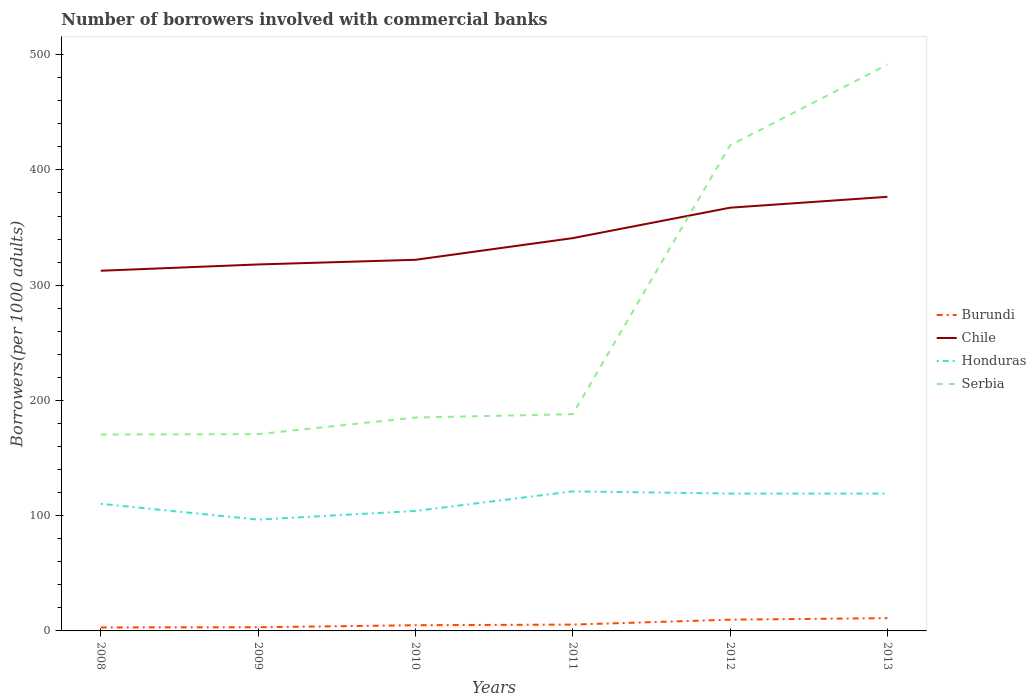Does the line corresponding to Chile intersect with the line corresponding to Honduras?
Give a very brief answer. No. Across all years, what is the maximum number of borrowers involved with commercial banks in Honduras?
Offer a very short reply. 96.61. What is the total number of borrowers involved with commercial banks in Serbia in the graph?
Provide a short and direct response. -14.4. What is the difference between the highest and the second highest number of borrowers involved with commercial banks in Chile?
Keep it short and to the point. 64.16. What is the difference between the highest and the lowest number of borrowers involved with commercial banks in Serbia?
Your answer should be compact. 2. Is the number of borrowers involved with commercial banks in Honduras strictly greater than the number of borrowers involved with commercial banks in Burundi over the years?
Provide a succinct answer. No. How many years are there in the graph?
Give a very brief answer. 6. What is the difference between two consecutive major ticks on the Y-axis?
Your answer should be compact. 100. Where does the legend appear in the graph?
Make the answer very short. Center right. What is the title of the graph?
Keep it short and to the point. Number of borrowers involved with commercial banks. Does "Suriname" appear as one of the legend labels in the graph?
Your answer should be very brief. No. What is the label or title of the X-axis?
Give a very brief answer. Years. What is the label or title of the Y-axis?
Provide a succinct answer. Borrowers(per 1000 adults). What is the Borrowers(per 1000 adults) of Burundi in 2008?
Keep it short and to the point. 3.02. What is the Borrowers(per 1000 adults) in Chile in 2008?
Keep it short and to the point. 312.53. What is the Borrowers(per 1000 adults) in Honduras in 2008?
Give a very brief answer. 110.29. What is the Borrowers(per 1000 adults) of Serbia in 2008?
Your response must be concise. 170.42. What is the Borrowers(per 1000 adults) of Burundi in 2009?
Make the answer very short. 3.19. What is the Borrowers(per 1000 adults) in Chile in 2009?
Provide a short and direct response. 317.99. What is the Borrowers(per 1000 adults) of Honduras in 2009?
Keep it short and to the point. 96.61. What is the Borrowers(per 1000 adults) of Serbia in 2009?
Your answer should be very brief. 170.75. What is the Borrowers(per 1000 adults) of Burundi in 2010?
Provide a succinct answer. 4.94. What is the Borrowers(per 1000 adults) of Chile in 2010?
Offer a very short reply. 322.03. What is the Borrowers(per 1000 adults) of Honduras in 2010?
Provide a succinct answer. 104.09. What is the Borrowers(per 1000 adults) of Serbia in 2010?
Offer a terse response. 185.15. What is the Borrowers(per 1000 adults) in Burundi in 2011?
Provide a succinct answer. 5.49. What is the Borrowers(per 1000 adults) in Chile in 2011?
Keep it short and to the point. 340.83. What is the Borrowers(per 1000 adults) in Honduras in 2011?
Your response must be concise. 121.07. What is the Borrowers(per 1000 adults) in Serbia in 2011?
Offer a very short reply. 188.1. What is the Borrowers(per 1000 adults) in Burundi in 2012?
Give a very brief answer. 9.75. What is the Borrowers(per 1000 adults) in Chile in 2012?
Provide a short and direct response. 367.24. What is the Borrowers(per 1000 adults) of Honduras in 2012?
Your answer should be very brief. 119.22. What is the Borrowers(per 1000 adults) of Serbia in 2012?
Ensure brevity in your answer.  421.31. What is the Borrowers(per 1000 adults) of Burundi in 2013?
Offer a very short reply. 11.09. What is the Borrowers(per 1000 adults) in Chile in 2013?
Make the answer very short. 376.7. What is the Borrowers(per 1000 adults) of Honduras in 2013?
Your response must be concise. 119.24. What is the Borrowers(per 1000 adults) in Serbia in 2013?
Make the answer very short. 491.32. Across all years, what is the maximum Borrowers(per 1000 adults) of Burundi?
Your answer should be compact. 11.09. Across all years, what is the maximum Borrowers(per 1000 adults) of Chile?
Offer a very short reply. 376.7. Across all years, what is the maximum Borrowers(per 1000 adults) in Honduras?
Give a very brief answer. 121.07. Across all years, what is the maximum Borrowers(per 1000 adults) in Serbia?
Offer a terse response. 491.32. Across all years, what is the minimum Borrowers(per 1000 adults) of Burundi?
Make the answer very short. 3.02. Across all years, what is the minimum Borrowers(per 1000 adults) of Chile?
Make the answer very short. 312.53. Across all years, what is the minimum Borrowers(per 1000 adults) in Honduras?
Your response must be concise. 96.61. Across all years, what is the minimum Borrowers(per 1000 adults) of Serbia?
Your response must be concise. 170.42. What is the total Borrowers(per 1000 adults) in Burundi in the graph?
Offer a very short reply. 37.47. What is the total Borrowers(per 1000 adults) in Chile in the graph?
Give a very brief answer. 2037.32. What is the total Borrowers(per 1000 adults) of Honduras in the graph?
Provide a succinct answer. 670.52. What is the total Borrowers(per 1000 adults) of Serbia in the graph?
Your answer should be compact. 1627.05. What is the difference between the Borrowers(per 1000 adults) in Burundi in 2008 and that in 2009?
Make the answer very short. -0.18. What is the difference between the Borrowers(per 1000 adults) in Chile in 2008 and that in 2009?
Provide a succinct answer. -5.46. What is the difference between the Borrowers(per 1000 adults) in Honduras in 2008 and that in 2009?
Offer a terse response. 13.68. What is the difference between the Borrowers(per 1000 adults) of Serbia in 2008 and that in 2009?
Make the answer very short. -0.33. What is the difference between the Borrowers(per 1000 adults) in Burundi in 2008 and that in 2010?
Your answer should be compact. -1.93. What is the difference between the Borrowers(per 1000 adults) in Chile in 2008 and that in 2010?
Offer a very short reply. -9.5. What is the difference between the Borrowers(per 1000 adults) in Honduras in 2008 and that in 2010?
Make the answer very short. 6.2. What is the difference between the Borrowers(per 1000 adults) in Serbia in 2008 and that in 2010?
Offer a terse response. -14.73. What is the difference between the Borrowers(per 1000 adults) of Burundi in 2008 and that in 2011?
Your response must be concise. -2.47. What is the difference between the Borrowers(per 1000 adults) of Chile in 2008 and that in 2011?
Provide a short and direct response. -28.3. What is the difference between the Borrowers(per 1000 adults) in Honduras in 2008 and that in 2011?
Provide a short and direct response. -10.78. What is the difference between the Borrowers(per 1000 adults) in Serbia in 2008 and that in 2011?
Your response must be concise. -17.67. What is the difference between the Borrowers(per 1000 adults) in Burundi in 2008 and that in 2012?
Offer a very short reply. -6.73. What is the difference between the Borrowers(per 1000 adults) in Chile in 2008 and that in 2012?
Provide a succinct answer. -54.71. What is the difference between the Borrowers(per 1000 adults) in Honduras in 2008 and that in 2012?
Give a very brief answer. -8.93. What is the difference between the Borrowers(per 1000 adults) in Serbia in 2008 and that in 2012?
Your answer should be compact. -250.88. What is the difference between the Borrowers(per 1000 adults) of Burundi in 2008 and that in 2013?
Provide a short and direct response. -8.07. What is the difference between the Borrowers(per 1000 adults) of Chile in 2008 and that in 2013?
Make the answer very short. -64.16. What is the difference between the Borrowers(per 1000 adults) of Honduras in 2008 and that in 2013?
Provide a succinct answer. -8.95. What is the difference between the Borrowers(per 1000 adults) in Serbia in 2008 and that in 2013?
Provide a succinct answer. -320.89. What is the difference between the Borrowers(per 1000 adults) of Burundi in 2009 and that in 2010?
Keep it short and to the point. -1.75. What is the difference between the Borrowers(per 1000 adults) in Chile in 2009 and that in 2010?
Provide a succinct answer. -4.04. What is the difference between the Borrowers(per 1000 adults) in Honduras in 2009 and that in 2010?
Offer a very short reply. -7.48. What is the difference between the Borrowers(per 1000 adults) in Serbia in 2009 and that in 2010?
Your answer should be compact. -14.4. What is the difference between the Borrowers(per 1000 adults) in Burundi in 2009 and that in 2011?
Your answer should be very brief. -2.3. What is the difference between the Borrowers(per 1000 adults) of Chile in 2009 and that in 2011?
Your answer should be very brief. -22.84. What is the difference between the Borrowers(per 1000 adults) of Honduras in 2009 and that in 2011?
Give a very brief answer. -24.46. What is the difference between the Borrowers(per 1000 adults) in Serbia in 2009 and that in 2011?
Keep it short and to the point. -17.35. What is the difference between the Borrowers(per 1000 adults) in Burundi in 2009 and that in 2012?
Your answer should be compact. -6.56. What is the difference between the Borrowers(per 1000 adults) in Chile in 2009 and that in 2012?
Your answer should be very brief. -49.25. What is the difference between the Borrowers(per 1000 adults) of Honduras in 2009 and that in 2012?
Your answer should be compact. -22.61. What is the difference between the Borrowers(per 1000 adults) of Serbia in 2009 and that in 2012?
Your answer should be compact. -250.56. What is the difference between the Borrowers(per 1000 adults) of Burundi in 2009 and that in 2013?
Your answer should be compact. -7.9. What is the difference between the Borrowers(per 1000 adults) in Chile in 2009 and that in 2013?
Provide a succinct answer. -58.7. What is the difference between the Borrowers(per 1000 adults) in Honduras in 2009 and that in 2013?
Make the answer very short. -22.63. What is the difference between the Borrowers(per 1000 adults) of Serbia in 2009 and that in 2013?
Your answer should be compact. -320.56. What is the difference between the Borrowers(per 1000 adults) in Burundi in 2010 and that in 2011?
Make the answer very short. -0.55. What is the difference between the Borrowers(per 1000 adults) in Chile in 2010 and that in 2011?
Ensure brevity in your answer.  -18.8. What is the difference between the Borrowers(per 1000 adults) in Honduras in 2010 and that in 2011?
Give a very brief answer. -16.98. What is the difference between the Borrowers(per 1000 adults) in Serbia in 2010 and that in 2011?
Offer a terse response. -2.94. What is the difference between the Borrowers(per 1000 adults) of Burundi in 2010 and that in 2012?
Give a very brief answer. -4.81. What is the difference between the Borrowers(per 1000 adults) in Chile in 2010 and that in 2012?
Offer a terse response. -45.21. What is the difference between the Borrowers(per 1000 adults) in Honduras in 2010 and that in 2012?
Your answer should be compact. -15.13. What is the difference between the Borrowers(per 1000 adults) of Serbia in 2010 and that in 2012?
Make the answer very short. -236.15. What is the difference between the Borrowers(per 1000 adults) in Burundi in 2010 and that in 2013?
Your response must be concise. -6.15. What is the difference between the Borrowers(per 1000 adults) of Chile in 2010 and that in 2013?
Your response must be concise. -54.66. What is the difference between the Borrowers(per 1000 adults) of Honduras in 2010 and that in 2013?
Ensure brevity in your answer.  -15.14. What is the difference between the Borrowers(per 1000 adults) of Serbia in 2010 and that in 2013?
Make the answer very short. -306.16. What is the difference between the Borrowers(per 1000 adults) in Burundi in 2011 and that in 2012?
Give a very brief answer. -4.26. What is the difference between the Borrowers(per 1000 adults) in Chile in 2011 and that in 2012?
Provide a short and direct response. -26.41. What is the difference between the Borrowers(per 1000 adults) of Honduras in 2011 and that in 2012?
Keep it short and to the point. 1.85. What is the difference between the Borrowers(per 1000 adults) in Serbia in 2011 and that in 2012?
Provide a succinct answer. -233.21. What is the difference between the Borrowers(per 1000 adults) of Burundi in 2011 and that in 2013?
Give a very brief answer. -5.6. What is the difference between the Borrowers(per 1000 adults) in Chile in 2011 and that in 2013?
Offer a terse response. -35.86. What is the difference between the Borrowers(per 1000 adults) in Honduras in 2011 and that in 2013?
Provide a succinct answer. 1.84. What is the difference between the Borrowers(per 1000 adults) in Serbia in 2011 and that in 2013?
Keep it short and to the point. -303.22. What is the difference between the Borrowers(per 1000 adults) of Burundi in 2012 and that in 2013?
Keep it short and to the point. -1.34. What is the difference between the Borrowers(per 1000 adults) in Chile in 2012 and that in 2013?
Ensure brevity in your answer.  -9.46. What is the difference between the Borrowers(per 1000 adults) in Honduras in 2012 and that in 2013?
Your answer should be very brief. -0.02. What is the difference between the Borrowers(per 1000 adults) in Serbia in 2012 and that in 2013?
Offer a very short reply. -70.01. What is the difference between the Borrowers(per 1000 adults) of Burundi in 2008 and the Borrowers(per 1000 adults) of Chile in 2009?
Ensure brevity in your answer.  -314.98. What is the difference between the Borrowers(per 1000 adults) of Burundi in 2008 and the Borrowers(per 1000 adults) of Honduras in 2009?
Provide a short and direct response. -93.59. What is the difference between the Borrowers(per 1000 adults) of Burundi in 2008 and the Borrowers(per 1000 adults) of Serbia in 2009?
Offer a very short reply. -167.74. What is the difference between the Borrowers(per 1000 adults) in Chile in 2008 and the Borrowers(per 1000 adults) in Honduras in 2009?
Your response must be concise. 215.92. What is the difference between the Borrowers(per 1000 adults) in Chile in 2008 and the Borrowers(per 1000 adults) in Serbia in 2009?
Your response must be concise. 141.78. What is the difference between the Borrowers(per 1000 adults) in Honduras in 2008 and the Borrowers(per 1000 adults) in Serbia in 2009?
Keep it short and to the point. -60.46. What is the difference between the Borrowers(per 1000 adults) in Burundi in 2008 and the Borrowers(per 1000 adults) in Chile in 2010?
Offer a very short reply. -319.02. What is the difference between the Borrowers(per 1000 adults) in Burundi in 2008 and the Borrowers(per 1000 adults) in Honduras in 2010?
Offer a very short reply. -101.08. What is the difference between the Borrowers(per 1000 adults) of Burundi in 2008 and the Borrowers(per 1000 adults) of Serbia in 2010?
Keep it short and to the point. -182.14. What is the difference between the Borrowers(per 1000 adults) in Chile in 2008 and the Borrowers(per 1000 adults) in Honduras in 2010?
Your answer should be very brief. 208.44. What is the difference between the Borrowers(per 1000 adults) of Chile in 2008 and the Borrowers(per 1000 adults) of Serbia in 2010?
Offer a terse response. 127.38. What is the difference between the Borrowers(per 1000 adults) of Honduras in 2008 and the Borrowers(per 1000 adults) of Serbia in 2010?
Keep it short and to the point. -74.86. What is the difference between the Borrowers(per 1000 adults) in Burundi in 2008 and the Borrowers(per 1000 adults) in Chile in 2011?
Provide a short and direct response. -337.82. What is the difference between the Borrowers(per 1000 adults) in Burundi in 2008 and the Borrowers(per 1000 adults) in Honduras in 2011?
Ensure brevity in your answer.  -118.06. What is the difference between the Borrowers(per 1000 adults) of Burundi in 2008 and the Borrowers(per 1000 adults) of Serbia in 2011?
Your answer should be compact. -185.08. What is the difference between the Borrowers(per 1000 adults) in Chile in 2008 and the Borrowers(per 1000 adults) in Honduras in 2011?
Ensure brevity in your answer.  191.46. What is the difference between the Borrowers(per 1000 adults) in Chile in 2008 and the Borrowers(per 1000 adults) in Serbia in 2011?
Your response must be concise. 124.43. What is the difference between the Borrowers(per 1000 adults) of Honduras in 2008 and the Borrowers(per 1000 adults) of Serbia in 2011?
Your answer should be very brief. -77.81. What is the difference between the Borrowers(per 1000 adults) in Burundi in 2008 and the Borrowers(per 1000 adults) in Chile in 2012?
Provide a succinct answer. -364.22. What is the difference between the Borrowers(per 1000 adults) in Burundi in 2008 and the Borrowers(per 1000 adults) in Honduras in 2012?
Offer a very short reply. -116.21. What is the difference between the Borrowers(per 1000 adults) in Burundi in 2008 and the Borrowers(per 1000 adults) in Serbia in 2012?
Your answer should be very brief. -418.29. What is the difference between the Borrowers(per 1000 adults) of Chile in 2008 and the Borrowers(per 1000 adults) of Honduras in 2012?
Ensure brevity in your answer.  193.31. What is the difference between the Borrowers(per 1000 adults) in Chile in 2008 and the Borrowers(per 1000 adults) in Serbia in 2012?
Give a very brief answer. -108.78. What is the difference between the Borrowers(per 1000 adults) of Honduras in 2008 and the Borrowers(per 1000 adults) of Serbia in 2012?
Give a very brief answer. -311.02. What is the difference between the Borrowers(per 1000 adults) in Burundi in 2008 and the Borrowers(per 1000 adults) in Chile in 2013?
Ensure brevity in your answer.  -373.68. What is the difference between the Borrowers(per 1000 adults) of Burundi in 2008 and the Borrowers(per 1000 adults) of Honduras in 2013?
Make the answer very short. -116.22. What is the difference between the Borrowers(per 1000 adults) in Burundi in 2008 and the Borrowers(per 1000 adults) in Serbia in 2013?
Give a very brief answer. -488.3. What is the difference between the Borrowers(per 1000 adults) of Chile in 2008 and the Borrowers(per 1000 adults) of Honduras in 2013?
Give a very brief answer. 193.29. What is the difference between the Borrowers(per 1000 adults) of Chile in 2008 and the Borrowers(per 1000 adults) of Serbia in 2013?
Your answer should be compact. -178.78. What is the difference between the Borrowers(per 1000 adults) in Honduras in 2008 and the Borrowers(per 1000 adults) in Serbia in 2013?
Provide a short and direct response. -381.02. What is the difference between the Borrowers(per 1000 adults) in Burundi in 2009 and the Borrowers(per 1000 adults) in Chile in 2010?
Offer a terse response. -318.84. What is the difference between the Borrowers(per 1000 adults) in Burundi in 2009 and the Borrowers(per 1000 adults) in Honduras in 2010?
Offer a very short reply. -100.9. What is the difference between the Borrowers(per 1000 adults) in Burundi in 2009 and the Borrowers(per 1000 adults) in Serbia in 2010?
Offer a very short reply. -181.96. What is the difference between the Borrowers(per 1000 adults) of Chile in 2009 and the Borrowers(per 1000 adults) of Honduras in 2010?
Your answer should be compact. 213.9. What is the difference between the Borrowers(per 1000 adults) in Chile in 2009 and the Borrowers(per 1000 adults) in Serbia in 2010?
Offer a terse response. 132.84. What is the difference between the Borrowers(per 1000 adults) of Honduras in 2009 and the Borrowers(per 1000 adults) of Serbia in 2010?
Provide a short and direct response. -88.54. What is the difference between the Borrowers(per 1000 adults) in Burundi in 2009 and the Borrowers(per 1000 adults) in Chile in 2011?
Your answer should be compact. -337.64. What is the difference between the Borrowers(per 1000 adults) of Burundi in 2009 and the Borrowers(per 1000 adults) of Honduras in 2011?
Your response must be concise. -117.88. What is the difference between the Borrowers(per 1000 adults) in Burundi in 2009 and the Borrowers(per 1000 adults) in Serbia in 2011?
Your answer should be very brief. -184.91. What is the difference between the Borrowers(per 1000 adults) in Chile in 2009 and the Borrowers(per 1000 adults) in Honduras in 2011?
Your response must be concise. 196.92. What is the difference between the Borrowers(per 1000 adults) of Chile in 2009 and the Borrowers(per 1000 adults) of Serbia in 2011?
Give a very brief answer. 129.89. What is the difference between the Borrowers(per 1000 adults) in Honduras in 2009 and the Borrowers(per 1000 adults) in Serbia in 2011?
Your answer should be compact. -91.49. What is the difference between the Borrowers(per 1000 adults) of Burundi in 2009 and the Borrowers(per 1000 adults) of Chile in 2012?
Your response must be concise. -364.05. What is the difference between the Borrowers(per 1000 adults) in Burundi in 2009 and the Borrowers(per 1000 adults) in Honduras in 2012?
Make the answer very short. -116.03. What is the difference between the Borrowers(per 1000 adults) of Burundi in 2009 and the Borrowers(per 1000 adults) of Serbia in 2012?
Provide a short and direct response. -418.12. What is the difference between the Borrowers(per 1000 adults) in Chile in 2009 and the Borrowers(per 1000 adults) in Honduras in 2012?
Offer a very short reply. 198.77. What is the difference between the Borrowers(per 1000 adults) in Chile in 2009 and the Borrowers(per 1000 adults) in Serbia in 2012?
Your response must be concise. -103.32. What is the difference between the Borrowers(per 1000 adults) of Honduras in 2009 and the Borrowers(per 1000 adults) of Serbia in 2012?
Ensure brevity in your answer.  -324.7. What is the difference between the Borrowers(per 1000 adults) in Burundi in 2009 and the Borrowers(per 1000 adults) in Chile in 2013?
Your answer should be very brief. -373.5. What is the difference between the Borrowers(per 1000 adults) in Burundi in 2009 and the Borrowers(per 1000 adults) in Honduras in 2013?
Your answer should be compact. -116.05. What is the difference between the Borrowers(per 1000 adults) of Burundi in 2009 and the Borrowers(per 1000 adults) of Serbia in 2013?
Offer a terse response. -488.12. What is the difference between the Borrowers(per 1000 adults) in Chile in 2009 and the Borrowers(per 1000 adults) in Honduras in 2013?
Keep it short and to the point. 198.75. What is the difference between the Borrowers(per 1000 adults) in Chile in 2009 and the Borrowers(per 1000 adults) in Serbia in 2013?
Your answer should be compact. -173.32. What is the difference between the Borrowers(per 1000 adults) of Honduras in 2009 and the Borrowers(per 1000 adults) of Serbia in 2013?
Provide a succinct answer. -394.71. What is the difference between the Borrowers(per 1000 adults) in Burundi in 2010 and the Borrowers(per 1000 adults) in Chile in 2011?
Keep it short and to the point. -335.89. What is the difference between the Borrowers(per 1000 adults) of Burundi in 2010 and the Borrowers(per 1000 adults) of Honduras in 2011?
Provide a succinct answer. -116.13. What is the difference between the Borrowers(per 1000 adults) in Burundi in 2010 and the Borrowers(per 1000 adults) in Serbia in 2011?
Offer a very short reply. -183.16. What is the difference between the Borrowers(per 1000 adults) of Chile in 2010 and the Borrowers(per 1000 adults) of Honduras in 2011?
Your response must be concise. 200.96. What is the difference between the Borrowers(per 1000 adults) in Chile in 2010 and the Borrowers(per 1000 adults) in Serbia in 2011?
Your answer should be compact. 133.93. What is the difference between the Borrowers(per 1000 adults) of Honduras in 2010 and the Borrowers(per 1000 adults) of Serbia in 2011?
Give a very brief answer. -84.01. What is the difference between the Borrowers(per 1000 adults) in Burundi in 2010 and the Borrowers(per 1000 adults) in Chile in 2012?
Ensure brevity in your answer.  -362.3. What is the difference between the Borrowers(per 1000 adults) of Burundi in 2010 and the Borrowers(per 1000 adults) of Honduras in 2012?
Your answer should be compact. -114.28. What is the difference between the Borrowers(per 1000 adults) in Burundi in 2010 and the Borrowers(per 1000 adults) in Serbia in 2012?
Keep it short and to the point. -416.37. What is the difference between the Borrowers(per 1000 adults) in Chile in 2010 and the Borrowers(per 1000 adults) in Honduras in 2012?
Make the answer very short. 202.81. What is the difference between the Borrowers(per 1000 adults) of Chile in 2010 and the Borrowers(per 1000 adults) of Serbia in 2012?
Your response must be concise. -99.28. What is the difference between the Borrowers(per 1000 adults) of Honduras in 2010 and the Borrowers(per 1000 adults) of Serbia in 2012?
Your response must be concise. -317.21. What is the difference between the Borrowers(per 1000 adults) in Burundi in 2010 and the Borrowers(per 1000 adults) in Chile in 2013?
Ensure brevity in your answer.  -371.75. What is the difference between the Borrowers(per 1000 adults) of Burundi in 2010 and the Borrowers(per 1000 adults) of Honduras in 2013?
Your response must be concise. -114.3. What is the difference between the Borrowers(per 1000 adults) in Burundi in 2010 and the Borrowers(per 1000 adults) in Serbia in 2013?
Your answer should be compact. -486.37. What is the difference between the Borrowers(per 1000 adults) in Chile in 2010 and the Borrowers(per 1000 adults) in Honduras in 2013?
Keep it short and to the point. 202.79. What is the difference between the Borrowers(per 1000 adults) in Chile in 2010 and the Borrowers(per 1000 adults) in Serbia in 2013?
Your answer should be compact. -169.28. What is the difference between the Borrowers(per 1000 adults) of Honduras in 2010 and the Borrowers(per 1000 adults) of Serbia in 2013?
Give a very brief answer. -387.22. What is the difference between the Borrowers(per 1000 adults) of Burundi in 2011 and the Borrowers(per 1000 adults) of Chile in 2012?
Offer a terse response. -361.75. What is the difference between the Borrowers(per 1000 adults) in Burundi in 2011 and the Borrowers(per 1000 adults) in Honduras in 2012?
Provide a short and direct response. -113.73. What is the difference between the Borrowers(per 1000 adults) in Burundi in 2011 and the Borrowers(per 1000 adults) in Serbia in 2012?
Offer a very short reply. -415.82. What is the difference between the Borrowers(per 1000 adults) in Chile in 2011 and the Borrowers(per 1000 adults) in Honduras in 2012?
Your answer should be compact. 221.61. What is the difference between the Borrowers(per 1000 adults) of Chile in 2011 and the Borrowers(per 1000 adults) of Serbia in 2012?
Make the answer very short. -80.47. What is the difference between the Borrowers(per 1000 adults) of Honduras in 2011 and the Borrowers(per 1000 adults) of Serbia in 2012?
Offer a very short reply. -300.24. What is the difference between the Borrowers(per 1000 adults) in Burundi in 2011 and the Borrowers(per 1000 adults) in Chile in 2013?
Make the answer very short. -371.21. What is the difference between the Borrowers(per 1000 adults) in Burundi in 2011 and the Borrowers(per 1000 adults) in Honduras in 2013?
Your answer should be very brief. -113.75. What is the difference between the Borrowers(per 1000 adults) in Burundi in 2011 and the Borrowers(per 1000 adults) in Serbia in 2013?
Provide a succinct answer. -485.83. What is the difference between the Borrowers(per 1000 adults) of Chile in 2011 and the Borrowers(per 1000 adults) of Honduras in 2013?
Keep it short and to the point. 221.6. What is the difference between the Borrowers(per 1000 adults) of Chile in 2011 and the Borrowers(per 1000 adults) of Serbia in 2013?
Give a very brief answer. -150.48. What is the difference between the Borrowers(per 1000 adults) of Honduras in 2011 and the Borrowers(per 1000 adults) of Serbia in 2013?
Your response must be concise. -370.24. What is the difference between the Borrowers(per 1000 adults) of Burundi in 2012 and the Borrowers(per 1000 adults) of Chile in 2013?
Give a very brief answer. -366.95. What is the difference between the Borrowers(per 1000 adults) of Burundi in 2012 and the Borrowers(per 1000 adults) of Honduras in 2013?
Ensure brevity in your answer.  -109.49. What is the difference between the Borrowers(per 1000 adults) in Burundi in 2012 and the Borrowers(per 1000 adults) in Serbia in 2013?
Give a very brief answer. -481.56. What is the difference between the Borrowers(per 1000 adults) of Chile in 2012 and the Borrowers(per 1000 adults) of Honduras in 2013?
Keep it short and to the point. 248. What is the difference between the Borrowers(per 1000 adults) in Chile in 2012 and the Borrowers(per 1000 adults) in Serbia in 2013?
Provide a succinct answer. -124.08. What is the difference between the Borrowers(per 1000 adults) in Honduras in 2012 and the Borrowers(per 1000 adults) in Serbia in 2013?
Your response must be concise. -372.09. What is the average Borrowers(per 1000 adults) of Burundi per year?
Your response must be concise. 6.25. What is the average Borrowers(per 1000 adults) of Chile per year?
Keep it short and to the point. 339.55. What is the average Borrowers(per 1000 adults) of Honduras per year?
Your response must be concise. 111.75. What is the average Borrowers(per 1000 adults) in Serbia per year?
Offer a terse response. 271.18. In the year 2008, what is the difference between the Borrowers(per 1000 adults) in Burundi and Borrowers(per 1000 adults) in Chile?
Your answer should be compact. -309.52. In the year 2008, what is the difference between the Borrowers(per 1000 adults) in Burundi and Borrowers(per 1000 adults) in Honduras?
Provide a short and direct response. -107.28. In the year 2008, what is the difference between the Borrowers(per 1000 adults) in Burundi and Borrowers(per 1000 adults) in Serbia?
Make the answer very short. -167.41. In the year 2008, what is the difference between the Borrowers(per 1000 adults) in Chile and Borrowers(per 1000 adults) in Honduras?
Make the answer very short. 202.24. In the year 2008, what is the difference between the Borrowers(per 1000 adults) in Chile and Borrowers(per 1000 adults) in Serbia?
Provide a succinct answer. 142.11. In the year 2008, what is the difference between the Borrowers(per 1000 adults) of Honduras and Borrowers(per 1000 adults) of Serbia?
Give a very brief answer. -60.13. In the year 2009, what is the difference between the Borrowers(per 1000 adults) in Burundi and Borrowers(per 1000 adults) in Chile?
Ensure brevity in your answer.  -314.8. In the year 2009, what is the difference between the Borrowers(per 1000 adults) in Burundi and Borrowers(per 1000 adults) in Honduras?
Your answer should be very brief. -93.42. In the year 2009, what is the difference between the Borrowers(per 1000 adults) of Burundi and Borrowers(per 1000 adults) of Serbia?
Provide a succinct answer. -167.56. In the year 2009, what is the difference between the Borrowers(per 1000 adults) in Chile and Borrowers(per 1000 adults) in Honduras?
Provide a short and direct response. 221.38. In the year 2009, what is the difference between the Borrowers(per 1000 adults) of Chile and Borrowers(per 1000 adults) of Serbia?
Offer a terse response. 147.24. In the year 2009, what is the difference between the Borrowers(per 1000 adults) in Honduras and Borrowers(per 1000 adults) in Serbia?
Provide a succinct answer. -74.14. In the year 2010, what is the difference between the Borrowers(per 1000 adults) of Burundi and Borrowers(per 1000 adults) of Chile?
Keep it short and to the point. -317.09. In the year 2010, what is the difference between the Borrowers(per 1000 adults) in Burundi and Borrowers(per 1000 adults) in Honduras?
Offer a very short reply. -99.15. In the year 2010, what is the difference between the Borrowers(per 1000 adults) of Burundi and Borrowers(per 1000 adults) of Serbia?
Make the answer very short. -180.21. In the year 2010, what is the difference between the Borrowers(per 1000 adults) of Chile and Borrowers(per 1000 adults) of Honduras?
Provide a succinct answer. 217.94. In the year 2010, what is the difference between the Borrowers(per 1000 adults) of Chile and Borrowers(per 1000 adults) of Serbia?
Ensure brevity in your answer.  136.88. In the year 2010, what is the difference between the Borrowers(per 1000 adults) of Honduras and Borrowers(per 1000 adults) of Serbia?
Make the answer very short. -81.06. In the year 2011, what is the difference between the Borrowers(per 1000 adults) in Burundi and Borrowers(per 1000 adults) in Chile?
Ensure brevity in your answer.  -335.35. In the year 2011, what is the difference between the Borrowers(per 1000 adults) of Burundi and Borrowers(per 1000 adults) of Honduras?
Provide a succinct answer. -115.58. In the year 2011, what is the difference between the Borrowers(per 1000 adults) in Burundi and Borrowers(per 1000 adults) in Serbia?
Your answer should be compact. -182.61. In the year 2011, what is the difference between the Borrowers(per 1000 adults) of Chile and Borrowers(per 1000 adults) of Honduras?
Your answer should be very brief. 219.76. In the year 2011, what is the difference between the Borrowers(per 1000 adults) in Chile and Borrowers(per 1000 adults) in Serbia?
Ensure brevity in your answer.  152.73. In the year 2011, what is the difference between the Borrowers(per 1000 adults) in Honduras and Borrowers(per 1000 adults) in Serbia?
Keep it short and to the point. -67.03. In the year 2012, what is the difference between the Borrowers(per 1000 adults) in Burundi and Borrowers(per 1000 adults) in Chile?
Give a very brief answer. -357.49. In the year 2012, what is the difference between the Borrowers(per 1000 adults) in Burundi and Borrowers(per 1000 adults) in Honduras?
Offer a very short reply. -109.47. In the year 2012, what is the difference between the Borrowers(per 1000 adults) in Burundi and Borrowers(per 1000 adults) in Serbia?
Provide a short and direct response. -411.56. In the year 2012, what is the difference between the Borrowers(per 1000 adults) of Chile and Borrowers(per 1000 adults) of Honduras?
Your answer should be compact. 248.02. In the year 2012, what is the difference between the Borrowers(per 1000 adults) of Chile and Borrowers(per 1000 adults) of Serbia?
Your answer should be very brief. -54.07. In the year 2012, what is the difference between the Borrowers(per 1000 adults) of Honduras and Borrowers(per 1000 adults) of Serbia?
Give a very brief answer. -302.09. In the year 2013, what is the difference between the Borrowers(per 1000 adults) of Burundi and Borrowers(per 1000 adults) of Chile?
Offer a very short reply. -365.61. In the year 2013, what is the difference between the Borrowers(per 1000 adults) of Burundi and Borrowers(per 1000 adults) of Honduras?
Your answer should be very brief. -108.15. In the year 2013, what is the difference between the Borrowers(per 1000 adults) in Burundi and Borrowers(per 1000 adults) in Serbia?
Offer a very short reply. -480.23. In the year 2013, what is the difference between the Borrowers(per 1000 adults) of Chile and Borrowers(per 1000 adults) of Honduras?
Your answer should be compact. 257.46. In the year 2013, what is the difference between the Borrowers(per 1000 adults) of Chile and Borrowers(per 1000 adults) of Serbia?
Provide a short and direct response. -114.62. In the year 2013, what is the difference between the Borrowers(per 1000 adults) of Honduras and Borrowers(per 1000 adults) of Serbia?
Offer a terse response. -372.08. What is the ratio of the Borrowers(per 1000 adults) in Burundi in 2008 to that in 2009?
Your response must be concise. 0.94. What is the ratio of the Borrowers(per 1000 adults) in Chile in 2008 to that in 2009?
Give a very brief answer. 0.98. What is the ratio of the Borrowers(per 1000 adults) of Honduras in 2008 to that in 2009?
Your answer should be very brief. 1.14. What is the ratio of the Borrowers(per 1000 adults) of Serbia in 2008 to that in 2009?
Your response must be concise. 1. What is the ratio of the Borrowers(per 1000 adults) in Burundi in 2008 to that in 2010?
Your answer should be compact. 0.61. What is the ratio of the Borrowers(per 1000 adults) of Chile in 2008 to that in 2010?
Make the answer very short. 0.97. What is the ratio of the Borrowers(per 1000 adults) of Honduras in 2008 to that in 2010?
Ensure brevity in your answer.  1.06. What is the ratio of the Borrowers(per 1000 adults) of Serbia in 2008 to that in 2010?
Give a very brief answer. 0.92. What is the ratio of the Borrowers(per 1000 adults) in Burundi in 2008 to that in 2011?
Ensure brevity in your answer.  0.55. What is the ratio of the Borrowers(per 1000 adults) of Chile in 2008 to that in 2011?
Make the answer very short. 0.92. What is the ratio of the Borrowers(per 1000 adults) in Honduras in 2008 to that in 2011?
Provide a succinct answer. 0.91. What is the ratio of the Borrowers(per 1000 adults) of Serbia in 2008 to that in 2011?
Your answer should be compact. 0.91. What is the ratio of the Borrowers(per 1000 adults) of Burundi in 2008 to that in 2012?
Your answer should be very brief. 0.31. What is the ratio of the Borrowers(per 1000 adults) in Chile in 2008 to that in 2012?
Your response must be concise. 0.85. What is the ratio of the Borrowers(per 1000 adults) of Honduras in 2008 to that in 2012?
Offer a terse response. 0.93. What is the ratio of the Borrowers(per 1000 adults) of Serbia in 2008 to that in 2012?
Offer a very short reply. 0.4. What is the ratio of the Borrowers(per 1000 adults) in Burundi in 2008 to that in 2013?
Provide a succinct answer. 0.27. What is the ratio of the Borrowers(per 1000 adults) of Chile in 2008 to that in 2013?
Give a very brief answer. 0.83. What is the ratio of the Borrowers(per 1000 adults) of Honduras in 2008 to that in 2013?
Your answer should be very brief. 0.93. What is the ratio of the Borrowers(per 1000 adults) of Serbia in 2008 to that in 2013?
Make the answer very short. 0.35. What is the ratio of the Borrowers(per 1000 adults) of Burundi in 2009 to that in 2010?
Offer a very short reply. 0.65. What is the ratio of the Borrowers(per 1000 adults) of Chile in 2009 to that in 2010?
Give a very brief answer. 0.99. What is the ratio of the Borrowers(per 1000 adults) of Honduras in 2009 to that in 2010?
Your answer should be compact. 0.93. What is the ratio of the Borrowers(per 1000 adults) of Serbia in 2009 to that in 2010?
Provide a succinct answer. 0.92. What is the ratio of the Borrowers(per 1000 adults) of Burundi in 2009 to that in 2011?
Your answer should be very brief. 0.58. What is the ratio of the Borrowers(per 1000 adults) of Chile in 2009 to that in 2011?
Your response must be concise. 0.93. What is the ratio of the Borrowers(per 1000 adults) in Honduras in 2009 to that in 2011?
Your response must be concise. 0.8. What is the ratio of the Borrowers(per 1000 adults) of Serbia in 2009 to that in 2011?
Offer a very short reply. 0.91. What is the ratio of the Borrowers(per 1000 adults) in Burundi in 2009 to that in 2012?
Offer a terse response. 0.33. What is the ratio of the Borrowers(per 1000 adults) of Chile in 2009 to that in 2012?
Offer a very short reply. 0.87. What is the ratio of the Borrowers(per 1000 adults) in Honduras in 2009 to that in 2012?
Provide a short and direct response. 0.81. What is the ratio of the Borrowers(per 1000 adults) of Serbia in 2009 to that in 2012?
Keep it short and to the point. 0.41. What is the ratio of the Borrowers(per 1000 adults) of Burundi in 2009 to that in 2013?
Give a very brief answer. 0.29. What is the ratio of the Borrowers(per 1000 adults) of Chile in 2009 to that in 2013?
Provide a short and direct response. 0.84. What is the ratio of the Borrowers(per 1000 adults) of Honduras in 2009 to that in 2013?
Give a very brief answer. 0.81. What is the ratio of the Borrowers(per 1000 adults) of Serbia in 2009 to that in 2013?
Make the answer very short. 0.35. What is the ratio of the Borrowers(per 1000 adults) in Burundi in 2010 to that in 2011?
Keep it short and to the point. 0.9. What is the ratio of the Borrowers(per 1000 adults) in Chile in 2010 to that in 2011?
Your response must be concise. 0.94. What is the ratio of the Borrowers(per 1000 adults) of Honduras in 2010 to that in 2011?
Your response must be concise. 0.86. What is the ratio of the Borrowers(per 1000 adults) in Serbia in 2010 to that in 2011?
Keep it short and to the point. 0.98. What is the ratio of the Borrowers(per 1000 adults) of Burundi in 2010 to that in 2012?
Your response must be concise. 0.51. What is the ratio of the Borrowers(per 1000 adults) in Chile in 2010 to that in 2012?
Keep it short and to the point. 0.88. What is the ratio of the Borrowers(per 1000 adults) in Honduras in 2010 to that in 2012?
Your answer should be compact. 0.87. What is the ratio of the Borrowers(per 1000 adults) of Serbia in 2010 to that in 2012?
Make the answer very short. 0.44. What is the ratio of the Borrowers(per 1000 adults) in Burundi in 2010 to that in 2013?
Your response must be concise. 0.45. What is the ratio of the Borrowers(per 1000 adults) of Chile in 2010 to that in 2013?
Your answer should be compact. 0.85. What is the ratio of the Borrowers(per 1000 adults) in Honduras in 2010 to that in 2013?
Give a very brief answer. 0.87. What is the ratio of the Borrowers(per 1000 adults) of Serbia in 2010 to that in 2013?
Provide a short and direct response. 0.38. What is the ratio of the Borrowers(per 1000 adults) in Burundi in 2011 to that in 2012?
Your answer should be very brief. 0.56. What is the ratio of the Borrowers(per 1000 adults) in Chile in 2011 to that in 2012?
Your answer should be compact. 0.93. What is the ratio of the Borrowers(per 1000 adults) in Honduras in 2011 to that in 2012?
Your answer should be very brief. 1.02. What is the ratio of the Borrowers(per 1000 adults) of Serbia in 2011 to that in 2012?
Provide a succinct answer. 0.45. What is the ratio of the Borrowers(per 1000 adults) in Burundi in 2011 to that in 2013?
Keep it short and to the point. 0.49. What is the ratio of the Borrowers(per 1000 adults) in Chile in 2011 to that in 2013?
Your answer should be compact. 0.9. What is the ratio of the Borrowers(per 1000 adults) of Honduras in 2011 to that in 2013?
Your response must be concise. 1.02. What is the ratio of the Borrowers(per 1000 adults) in Serbia in 2011 to that in 2013?
Give a very brief answer. 0.38. What is the ratio of the Borrowers(per 1000 adults) in Burundi in 2012 to that in 2013?
Give a very brief answer. 0.88. What is the ratio of the Borrowers(per 1000 adults) of Chile in 2012 to that in 2013?
Ensure brevity in your answer.  0.97. What is the ratio of the Borrowers(per 1000 adults) in Honduras in 2012 to that in 2013?
Your answer should be very brief. 1. What is the ratio of the Borrowers(per 1000 adults) of Serbia in 2012 to that in 2013?
Offer a terse response. 0.86. What is the difference between the highest and the second highest Borrowers(per 1000 adults) in Burundi?
Give a very brief answer. 1.34. What is the difference between the highest and the second highest Borrowers(per 1000 adults) in Chile?
Your answer should be very brief. 9.46. What is the difference between the highest and the second highest Borrowers(per 1000 adults) of Honduras?
Offer a terse response. 1.84. What is the difference between the highest and the second highest Borrowers(per 1000 adults) in Serbia?
Provide a short and direct response. 70.01. What is the difference between the highest and the lowest Borrowers(per 1000 adults) of Burundi?
Your answer should be very brief. 8.07. What is the difference between the highest and the lowest Borrowers(per 1000 adults) in Chile?
Provide a short and direct response. 64.16. What is the difference between the highest and the lowest Borrowers(per 1000 adults) of Honduras?
Ensure brevity in your answer.  24.46. What is the difference between the highest and the lowest Borrowers(per 1000 adults) in Serbia?
Provide a succinct answer. 320.89. 